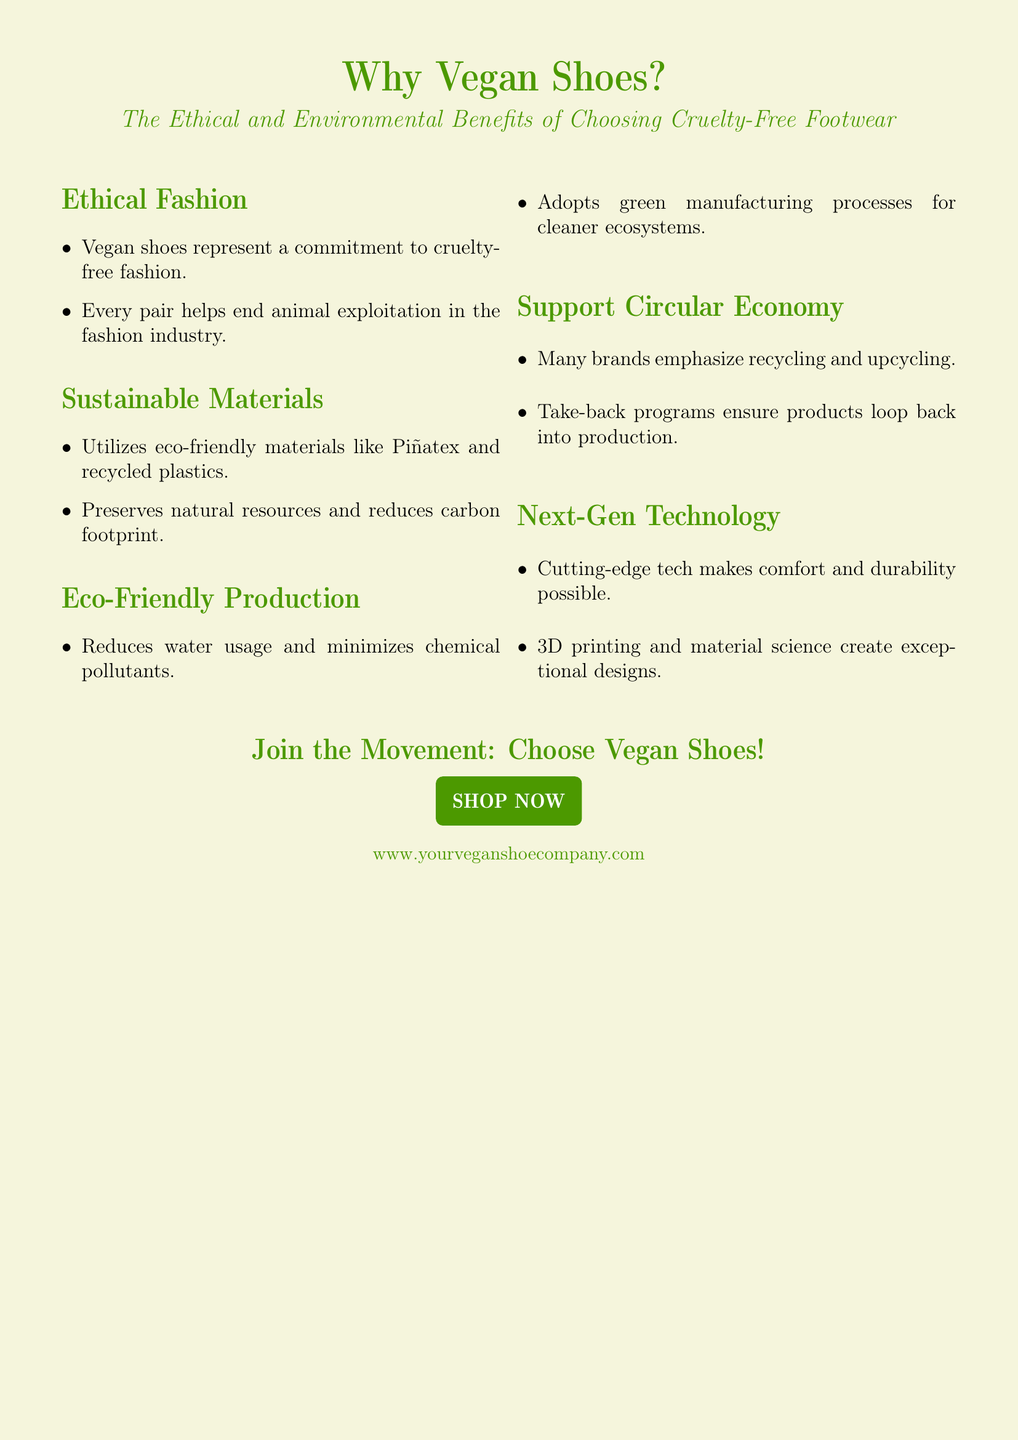What is the title of the document? The title can be found at the top of the document and indicates the main topic.
Answer: Why Vegan Shoes? What color is used for the background of the document? The color of the document's background is specified in the code.
Answer: Vegan beige What is one sustainable material mentioned? The document lists materials used in vegan shoes, highlighting environmental considerations.
Answer: Piñatex What type of production process is emphasized for vegan shoes? The document describes the production methods that reduce environmental impact.
Answer: Eco-Friendly Production What will choosing vegan shoes help end? The document states the broader ethical implication of selecting vegan footwear.
Answer: Animal exploitation How do many brands support a circular economy? The document mentions specific practices brands employ to promote sustainability.
Answer: Recycling and upcycling What does the document suggest about next-gen technology? The mention of advanced technology relates to the qualities of vegan shoes discussed.
Answer: Comfort and durability What action does the document encourage? The closing sections often promote direct action for the reader, encouraging engagement.
Answer: Choose Vegan Shoes! 